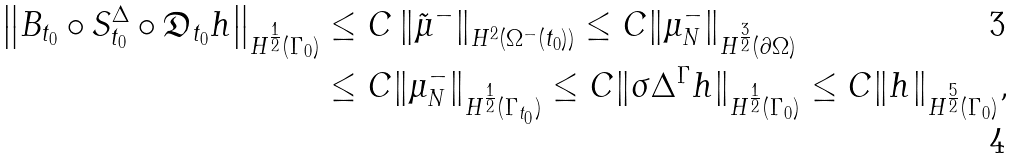<formula> <loc_0><loc_0><loc_500><loc_500>\left \| B _ { t _ { 0 } } \circ S _ { t _ { 0 } } ^ { \Delta } \circ \mathfrak { D } _ { t _ { 0 } } h \right \| _ { H ^ { \frac { 1 } { 2 } } ( \Gamma _ { 0 } ) } & \leq C \left \| \tilde { \mu } ^ { - } \right \| _ { H ^ { 2 } ( \Omega ^ { - } ( t _ { 0 } ) ) } \leq C \| \mu _ { N } ^ { - } \| _ { H ^ { \frac { 3 } { 2 } } ( \partial \Omega ) } \\ & \leq C \| \mu _ { N } ^ { - } \| _ { H ^ { \frac { 1 } { 2 } } ( \Gamma _ { t _ { 0 } } ) } \leq C \| \sigma \Delta ^ { \Gamma } h \| _ { H ^ { \frac { 1 } { 2 } } ( \Gamma _ { 0 } ) } \leq C \| h \| _ { H ^ { \frac { 5 } { 2 } } ( \Gamma _ { 0 } ) } ,</formula> 